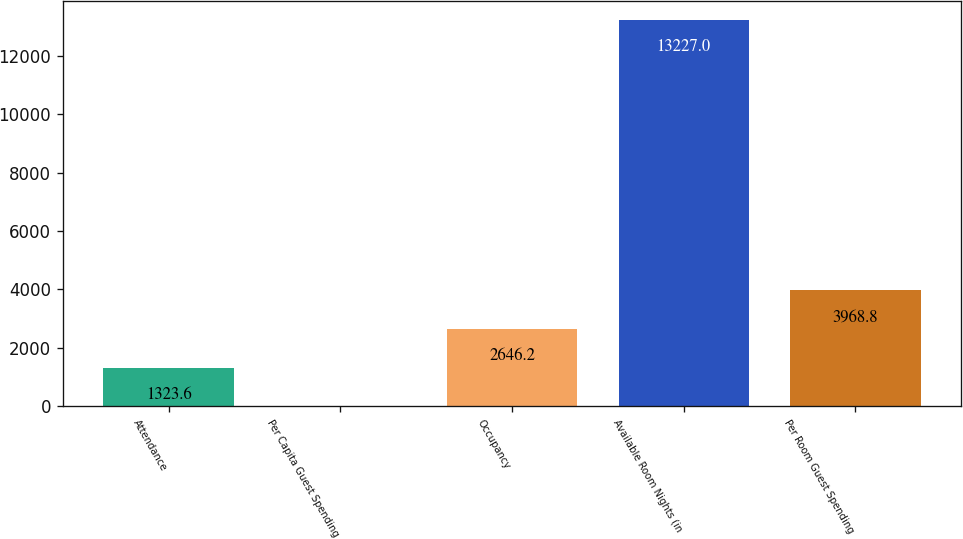Convert chart. <chart><loc_0><loc_0><loc_500><loc_500><bar_chart><fcel>Attendance<fcel>Per Capita Guest Spending<fcel>Occupancy<fcel>Available Room Nights (in<fcel>Per Room Guest Spending<nl><fcel>1323.6<fcel>1<fcel>2646.2<fcel>13227<fcel>3968.8<nl></chart> 